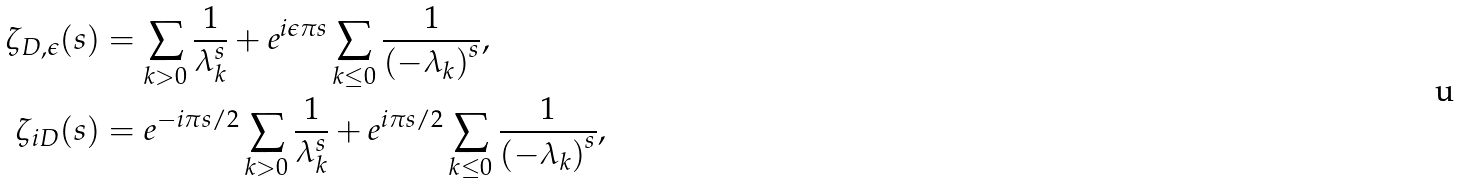Convert formula to latex. <formula><loc_0><loc_0><loc_500><loc_500>\zeta _ { D , \epsilon } ( s ) & = \sum _ { k > 0 } \frac { 1 } { \lambda _ { k } ^ { s } } + e ^ { i \epsilon \pi s } \sum _ { k \leq 0 } \frac { 1 } { { ( - \lambda _ { k } ) } ^ { s } } , \\ \zeta _ { i D } ( s ) & = e ^ { - i \pi s / 2 } \sum _ { k > 0 } \frac { 1 } { \lambda _ { k } ^ { s } } + e ^ { i \pi s / 2 } \sum _ { k \leq 0 } \frac { 1 } { { ( - \lambda _ { k } ) } ^ { s } } ,</formula> 